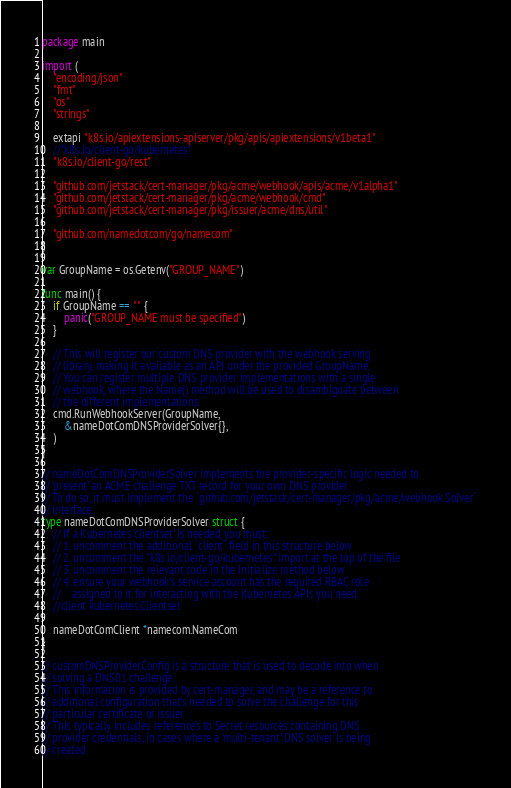Convert code to text. <code><loc_0><loc_0><loc_500><loc_500><_Go_>package main

import (
	"encoding/json"
	"fmt"
	"os"
	"strings"

	extapi "k8s.io/apiextensions-apiserver/pkg/apis/apiextensions/v1beta1"
	//"k8s.io/client-go/kubernetes"
	"k8s.io/client-go/rest"

	"github.com/jetstack/cert-manager/pkg/acme/webhook/apis/acme/v1alpha1"
	"github.com/jetstack/cert-manager/pkg/acme/webhook/cmd"
	"github.com/jetstack/cert-manager/pkg/issuer/acme/dns/util"

	"github.com/namedotcom/go/namecom"
)

var GroupName = os.Getenv("GROUP_NAME")

func main() {
	if GroupName == "" {
		panic("GROUP_NAME must be specified")
	}

	// This will register our custom DNS provider with the webhook serving
	// library, making it available as an API under the provided GroupName.
	// You can register multiple DNS provider implementations with a single
	// webhook, where the Name() method will be used to disambiguate between
	// the different implementations.
	cmd.RunWebhookServer(GroupName,
		&nameDotComDNSProviderSolver{},
	)
}

// nameDotComDNSProviderSolver implements the provider-specific logic needed to
// 'present' an ACME challenge TXT record for your own DNS provider.
// To do so, it must implement the `github.com/jetstack/cert-manager/pkg/acme/webhook.Solver`
// interface.
type nameDotComDNSProviderSolver struct {
	// If a Kubernetes 'clientset' is needed, you must:
	// 1. uncomment the additional `client` field in this structure below
	// 2. uncomment the "k8s.io/client-go/kubernetes" import at the top of the file
	// 3. uncomment the relevant code in the Initialize method below
	// 4. ensure your webhook's service account has the required RBAC role
	//    assigned to it for interacting with the Kubernetes APIs you need.
	//client kubernetes.Clientset

	nameDotComClient *namecom.NameCom
}

// customDNSProviderConfig is a structure that is used to decode into when
// solving a DNS01 challenge.
// This information is provided by cert-manager, and may be a reference to
// additional configuration that's needed to solve the challenge for this
// particular certificate or issuer.
// This typically includes references to Secret resources containing DNS
// provider credentials, in cases where a 'multi-tenant' DNS solver is being
// created.</code> 